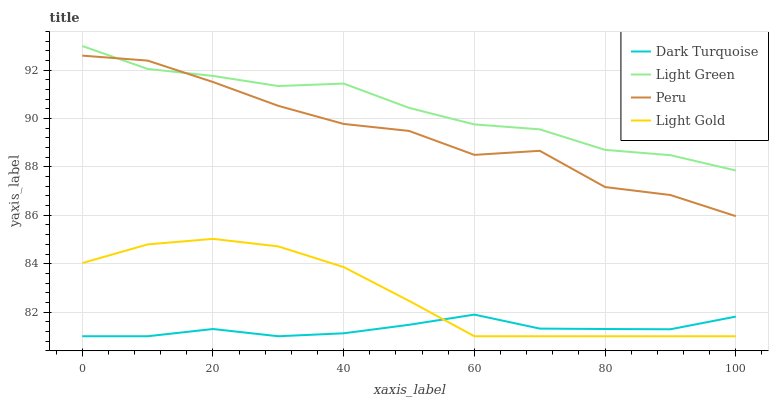Does Light Gold have the minimum area under the curve?
Answer yes or no. No. Does Light Gold have the maximum area under the curve?
Answer yes or no. No. Is Peru the smoothest?
Answer yes or no. No. Is Light Gold the roughest?
Answer yes or no. No. Does Peru have the lowest value?
Answer yes or no. No. Does Light Gold have the highest value?
Answer yes or no. No. Is Dark Turquoise less than Peru?
Answer yes or no. Yes. Is Light Green greater than Light Gold?
Answer yes or no. Yes. Does Dark Turquoise intersect Peru?
Answer yes or no. No. 